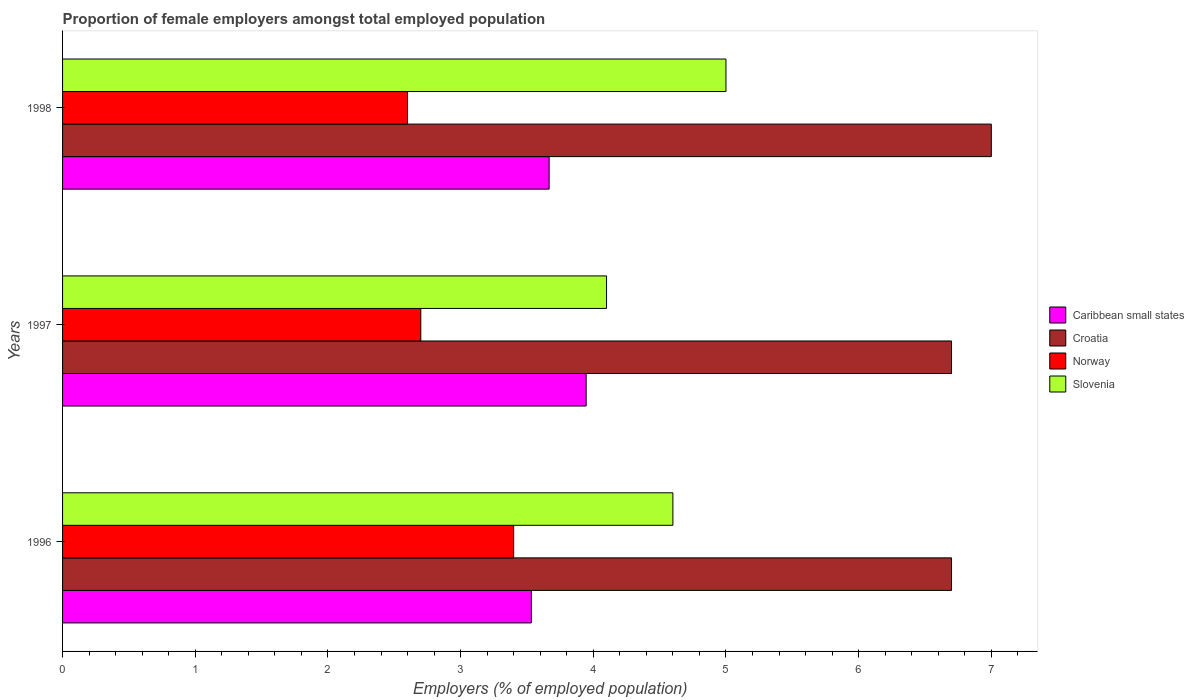How many different coloured bars are there?
Your response must be concise. 4. What is the label of the 2nd group of bars from the top?
Your answer should be compact. 1997. In how many cases, is the number of bars for a given year not equal to the number of legend labels?
Give a very brief answer. 0. What is the proportion of female employers in Croatia in 1997?
Offer a very short reply. 6.7. Across all years, what is the maximum proportion of female employers in Norway?
Your answer should be compact. 3.4. Across all years, what is the minimum proportion of female employers in Norway?
Offer a very short reply. 2.6. In which year was the proportion of female employers in Slovenia maximum?
Your answer should be compact. 1998. What is the total proportion of female employers in Caribbean small states in the graph?
Your answer should be compact. 11.15. What is the difference between the proportion of female employers in Caribbean small states in 1997 and that in 1998?
Offer a terse response. 0.28. What is the difference between the proportion of female employers in Slovenia in 1998 and the proportion of female employers in Croatia in 1997?
Keep it short and to the point. -1.7. What is the average proportion of female employers in Caribbean small states per year?
Your answer should be very brief. 3.72. In the year 1997, what is the difference between the proportion of female employers in Caribbean small states and proportion of female employers in Slovenia?
Offer a very short reply. -0.15. In how many years, is the proportion of female employers in Norway greater than 0.2 %?
Give a very brief answer. 3. What is the ratio of the proportion of female employers in Caribbean small states in 1997 to that in 1998?
Give a very brief answer. 1.08. Is the proportion of female employers in Croatia in 1996 less than that in 1997?
Give a very brief answer. No. Is the difference between the proportion of female employers in Caribbean small states in 1996 and 1998 greater than the difference between the proportion of female employers in Slovenia in 1996 and 1998?
Provide a short and direct response. Yes. What is the difference between the highest and the second highest proportion of female employers in Caribbean small states?
Your response must be concise. 0.28. What is the difference between the highest and the lowest proportion of female employers in Croatia?
Provide a short and direct response. 0.3. In how many years, is the proportion of female employers in Croatia greater than the average proportion of female employers in Croatia taken over all years?
Make the answer very short. 1. What does the 3rd bar from the top in 1998 represents?
Offer a terse response. Croatia. What does the 1st bar from the bottom in 1997 represents?
Offer a terse response. Caribbean small states. Is it the case that in every year, the sum of the proportion of female employers in Caribbean small states and proportion of female employers in Slovenia is greater than the proportion of female employers in Croatia?
Offer a very short reply. Yes. How many bars are there?
Ensure brevity in your answer.  12. What is the difference between two consecutive major ticks on the X-axis?
Keep it short and to the point. 1. Does the graph contain any zero values?
Offer a very short reply. No. Does the graph contain grids?
Ensure brevity in your answer.  No. Where does the legend appear in the graph?
Give a very brief answer. Center right. What is the title of the graph?
Provide a short and direct response. Proportion of female employers amongst total employed population. Does "World" appear as one of the legend labels in the graph?
Your answer should be compact. No. What is the label or title of the X-axis?
Your response must be concise. Employers (% of employed population). What is the Employers (% of employed population) in Caribbean small states in 1996?
Give a very brief answer. 3.53. What is the Employers (% of employed population) of Croatia in 1996?
Make the answer very short. 6.7. What is the Employers (% of employed population) in Norway in 1996?
Your answer should be very brief. 3.4. What is the Employers (% of employed population) in Slovenia in 1996?
Your response must be concise. 4.6. What is the Employers (% of employed population) of Caribbean small states in 1997?
Ensure brevity in your answer.  3.95. What is the Employers (% of employed population) of Croatia in 1997?
Offer a terse response. 6.7. What is the Employers (% of employed population) in Norway in 1997?
Offer a very short reply. 2.7. What is the Employers (% of employed population) in Slovenia in 1997?
Your response must be concise. 4.1. What is the Employers (% of employed population) in Caribbean small states in 1998?
Offer a very short reply. 3.67. What is the Employers (% of employed population) of Croatia in 1998?
Your answer should be compact. 7. What is the Employers (% of employed population) of Norway in 1998?
Ensure brevity in your answer.  2.6. What is the Employers (% of employed population) in Slovenia in 1998?
Offer a very short reply. 5. Across all years, what is the maximum Employers (% of employed population) of Caribbean small states?
Give a very brief answer. 3.95. Across all years, what is the maximum Employers (% of employed population) of Norway?
Provide a succinct answer. 3.4. Across all years, what is the minimum Employers (% of employed population) of Caribbean small states?
Provide a succinct answer. 3.53. Across all years, what is the minimum Employers (% of employed population) of Croatia?
Your answer should be compact. 6.7. Across all years, what is the minimum Employers (% of employed population) of Norway?
Your response must be concise. 2.6. Across all years, what is the minimum Employers (% of employed population) in Slovenia?
Provide a succinct answer. 4.1. What is the total Employers (% of employed population) in Caribbean small states in the graph?
Provide a succinct answer. 11.15. What is the total Employers (% of employed population) in Croatia in the graph?
Provide a short and direct response. 20.4. What is the total Employers (% of employed population) of Norway in the graph?
Provide a short and direct response. 8.7. What is the difference between the Employers (% of employed population) in Caribbean small states in 1996 and that in 1997?
Your answer should be compact. -0.41. What is the difference between the Employers (% of employed population) of Croatia in 1996 and that in 1997?
Provide a succinct answer. 0. What is the difference between the Employers (% of employed population) in Slovenia in 1996 and that in 1997?
Keep it short and to the point. 0.5. What is the difference between the Employers (% of employed population) of Caribbean small states in 1996 and that in 1998?
Provide a succinct answer. -0.13. What is the difference between the Employers (% of employed population) of Caribbean small states in 1997 and that in 1998?
Your answer should be compact. 0.28. What is the difference between the Employers (% of employed population) of Croatia in 1997 and that in 1998?
Your answer should be very brief. -0.3. What is the difference between the Employers (% of employed population) of Norway in 1997 and that in 1998?
Your response must be concise. 0.1. What is the difference between the Employers (% of employed population) in Slovenia in 1997 and that in 1998?
Your response must be concise. -0.9. What is the difference between the Employers (% of employed population) in Caribbean small states in 1996 and the Employers (% of employed population) in Croatia in 1997?
Keep it short and to the point. -3.17. What is the difference between the Employers (% of employed population) of Caribbean small states in 1996 and the Employers (% of employed population) of Norway in 1997?
Your answer should be very brief. 0.83. What is the difference between the Employers (% of employed population) of Caribbean small states in 1996 and the Employers (% of employed population) of Slovenia in 1997?
Give a very brief answer. -0.57. What is the difference between the Employers (% of employed population) of Croatia in 1996 and the Employers (% of employed population) of Norway in 1997?
Your answer should be compact. 4. What is the difference between the Employers (% of employed population) in Norway in 1996 and the Employers (% of employed population) in Slovenia in 1997?
Offer a very short reply. -0.7. What is the difference between the Employers (% of employed population) in Caribbean small states in 1996 and the Employers (% of employed population) in Croatia in 1998?
Make the answer very short. -3.47. What is the difference between the Employers (% of employed population) in Caribbean small states in 1996 and the Employers (% of employed population) in Norway in 1998?
Keep it short and to the point. 0.93. What is the difference between the Employers (% of employed population) in Caribbean small states in 1996 and the Employers (% of employed population) in Slovenia in 1998?
Provide a succinct answer. -1.47. What is the difference between the Employers (% of employed population) of Norway in 1996 and the Employers (% of employed population) of Slovenia in 1998?
Ensure brevity in your answer.  -1.6. What is the difference between the Employers (% of employed population) in Caribbean small states in 1997 and the Employers (% of employed population) in Croatia in 1998?
Offer a terse response. -3.05. What is the difference between the Employers (% of employed population) of Caribbean small states in 1997 and the Employers (% of employed population) of Norway in 1998?
Provide a succinct answer. 1.35. What is the difference between the Employers (% of employed population) of Caribbean small states in 1997 and the Employers (% of employed population) of Slovenia in 1998?
Give a very brief answer. -1.05. What is the difference between the Employers (% of employed population) of Croatia in 1997 and the Employers (% of employed population) of Norway in 1998?
Ensure brevity in your answer.  4.1. What is the difference between the Employers (% of employed population) in Croatia in 1997 and the Employers (% of employed population) in Slovenia in 1998?
Keep it short and to the point. 1.7. What is the average Employers (% of employed population) in Caribbean small states per year?
Your answer should be very brief. 3.72. What is the average Employers (% of employed population) in Croatia per year?
Provide a short and direct response. 6.8. What is the average Employers (% of employed population) in Slovenia per year?
Provide a succinct answer. 4.57. In the year 1996, what is the difference between the Employers (% of employed population) of Caribbean small states and Employers (% of employed population) of Croatia?
Make the answer very short. -3.17. In the year 1996, what is the difference between the Employers (% of employed population) in Caribbean small states and Employers (% of employed population) in Norway?
Your response must be concise. 0.13. In the year 1996, what is the difference between the Employers (% of employed population) in Caribbean small states and Employers (% of employed population) in Slovenia?
Your response must be concise. -1.07. In the year 1996, what is the difference between the Employers (% of employed population) of Croatia and Employers (% of employed population) of Norway?
Make the answer very short. 3.3. In the year 1997, what is the difference between the Employers (% of employed population) in Caribbean small states and Employers (% of employed population) in Croatia?
Offer a very short reply. -2.75. In the year 1997, what is the difference between the Employers (% of employed population) in Caribbean small states and Employers (% of employed population) in Norway?
Your response must be concise. 1.25. In the year 1997, what is the difference between the Employers (% of employed population) in Caribbean small states and Employers (% of employed population) in Slovenia?
Your answer should be very brief. -0.15. In the year 1997, what is the difference between the Employers (% of employed population) in Croatia and Employers (% of employed population) in Norway?
Offer a terse response. 4. In the year 1997, what is the difference between the Employers (% of employed population) in Croatia and Employers (% of employed population) in Slovenia?
Offer a terse response. 2.6. In the year 1997, what is the difference between the Employers (% of employed population) of Norway and Employers (% of employed population) of Slovenia?
Your answer should be compact. -1.4. In the year 1998, what is the difference between the Employers (% of employed population) in Caribbean small states and Employers (% of employed population) in Croatia?
Offer a very short reply. -3.33. In the year 1998, what is the difference between the Employers (% of employed population) in Caribbean small states and Employers (% of employed population) in Norway?
Make the answer very short. 1.07. In the year 1998, what is the difference between the Employers (% of employed population) in Caribbean small states and Employers (% of employed population) in Slovenia?
Make the answer very short. -1.33. In the year 1998, what is the difference between the Employers (% of employed population) in Croatia and Employers (% of employed population) in Norway?
Your answer should be very brief. 4.4. What is the ratio of the Employers (% of employed population) of Caribbean small states in 1996 to that in 1997?
Ensure brevity in your answer.  0.9. What is the ratio of the Employers (% of employed population) in Norway in 1996 to that in 1997?
Your answer should be very brief. 1.26. What is the ratio of the Employers (% of employed population) in Slovenia in 1996 to that in 1997?
Your answer should be very brief. 1.12. What is the ratio of the Employers (% of employed population) in Caribbean small states in 1996 to that in 1998?
Provide a short and direct response. 0.96. What is the ratio of the Employers (% of employed population) of Croatia in 1996 to that in 1998?
Make the answer very short. 0.96. What is the ratio of the Employers (% of employed population) of Norway in 1996 to that in 1998?
Your answer should be compact. 1.31. What is the ratio of the Employers (% of employed population) of Slovenia in 1996 to that in 1998?
Provide a succinct answer. 0.92. What is the ratio of the Employers (% of employed population) in Caribbean small states in 1997 to that in 1998?
Make the answer very short. 1.08. What is the ratio of the Employers (% of employed population) of Croatia in 1997 to that in 1998?
Give a very brief answer. 0.96. What is the ratio of the Employers (% of employed population) of Norway in 1997 to that in 1998?
Provide a short and direct response. 1.04. What is the ratio of the Employers (% of employed population) in Slovenia in 1997 to that in 1998?
Your answer should be compact. 0.82. What is the difference between the highest and the second highest Employers (% of employed population) in Caribbean small states?
Provide a succinct answer. 0.28. What is the difference between the highest and the second highest Employers (% of employed population) in Croatia?
Your answer should be compact. 0.3. What is the difference between the highest and the lowest Employers (% of employed population) of Caribbean small states?
Your answer should be compact. 0.41. What is the difference between the highest and the lowest Employers (% of employed population) in Slovenia?
Make the answer very short. 0.9. 